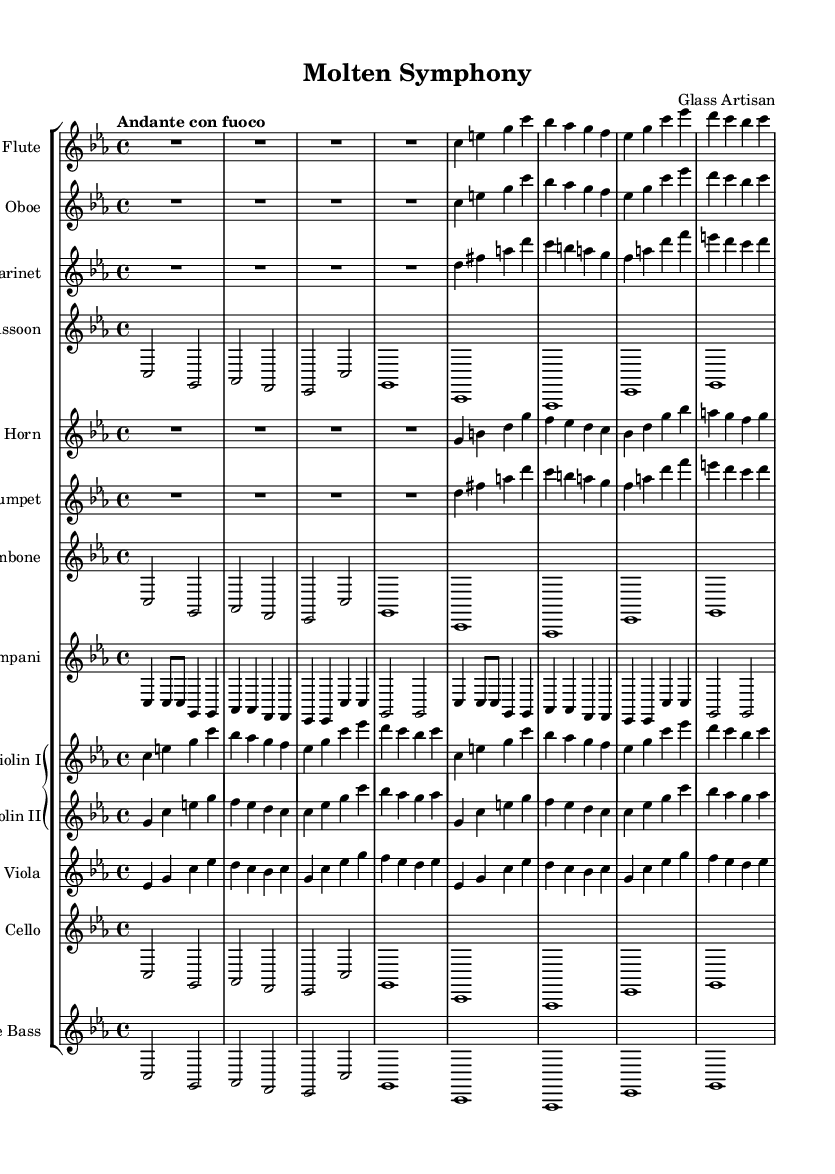What is the key signature of this music? The key signature is identified by looking at the beginning of the staff where it indicates the notes that are sharp or flat. In this case, there are no sharps or flats, meaning the piece is in C major, which has no accidentals.
Answer: C minor What is the time signature of this music? The time signature is located at the beginning of the score. Here, it shows a 4/4 time signature, which indicates four beats in a measure and the quarter note gets one beat.
Answer: 4/4 What tempo marking is indicated in this music? The tempo marking can be found above the staff. In this case, it is written as "Andante con fuoco," suggesting a moderate pace with some fire, implying a more spirited mood.
Answer: Andante con fuoco How many instruments are featured in this symphony? To determine the number of instruments, count each distinct staff in the score. In this sheet music, there are 12 individual staves, each representing a different instrument.
Answer: 12 Which brass instruments are included in the ensemble? The brass instruments can be identified by their specific staves in the score. Here, the trumpet, horn, and trombone are present as the brass section instruments.
Answer: Trumpet, horn, trombone What is the rhythmic pattern for the timpani in the first section? To find the timpani's rhythmic pattern, look specifically at the notes written for the timpani staff during the first measures. The pattern starts with quarter notes and eighth notes, indicating a steady, driving rhythm.
Answer: Quarter notes, eighth notes What does the term "molten" signify in the context of this symphony? The term "molten" in the title conveys the idea of fluidity and transformation, mirroring the glassblowing process where glass is heated and shaped—reflecting both the physicality of glass and the emotions depicted in the music.
Answer: Fluidity 